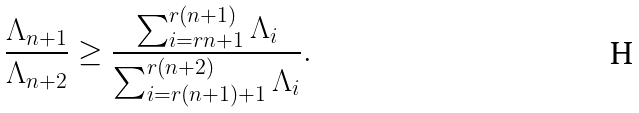<formula> <loc_0><loc_0><loc_500><loc_500>\frac { \Lambda _ { n + 1 } } { \Lambda _ { n + 2 } } \geq \frac { \sum ^ { r ( n + 1 ) } _ { i = r n + 1 } \Lambda _ { i } } { \sum ^ { r ( n + 2 ) } _ { i = r ( n + 1 ) + 1 } \Lambda _ { i } } .</formula> 